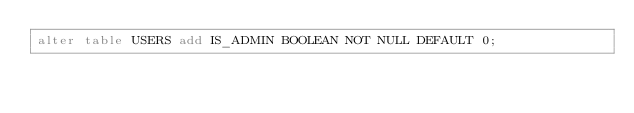Convert code to text. <code><loc_0><loc_0><loc_500><loc_500><_SQL_>alter table USERS add IS_ADMIN BOOLEAN NOT NULL DEFAULT 0;</code> 